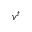<formula> <loc_0><loc_0><loc_500><loc_500>{ v } ^ { t }</formula> 